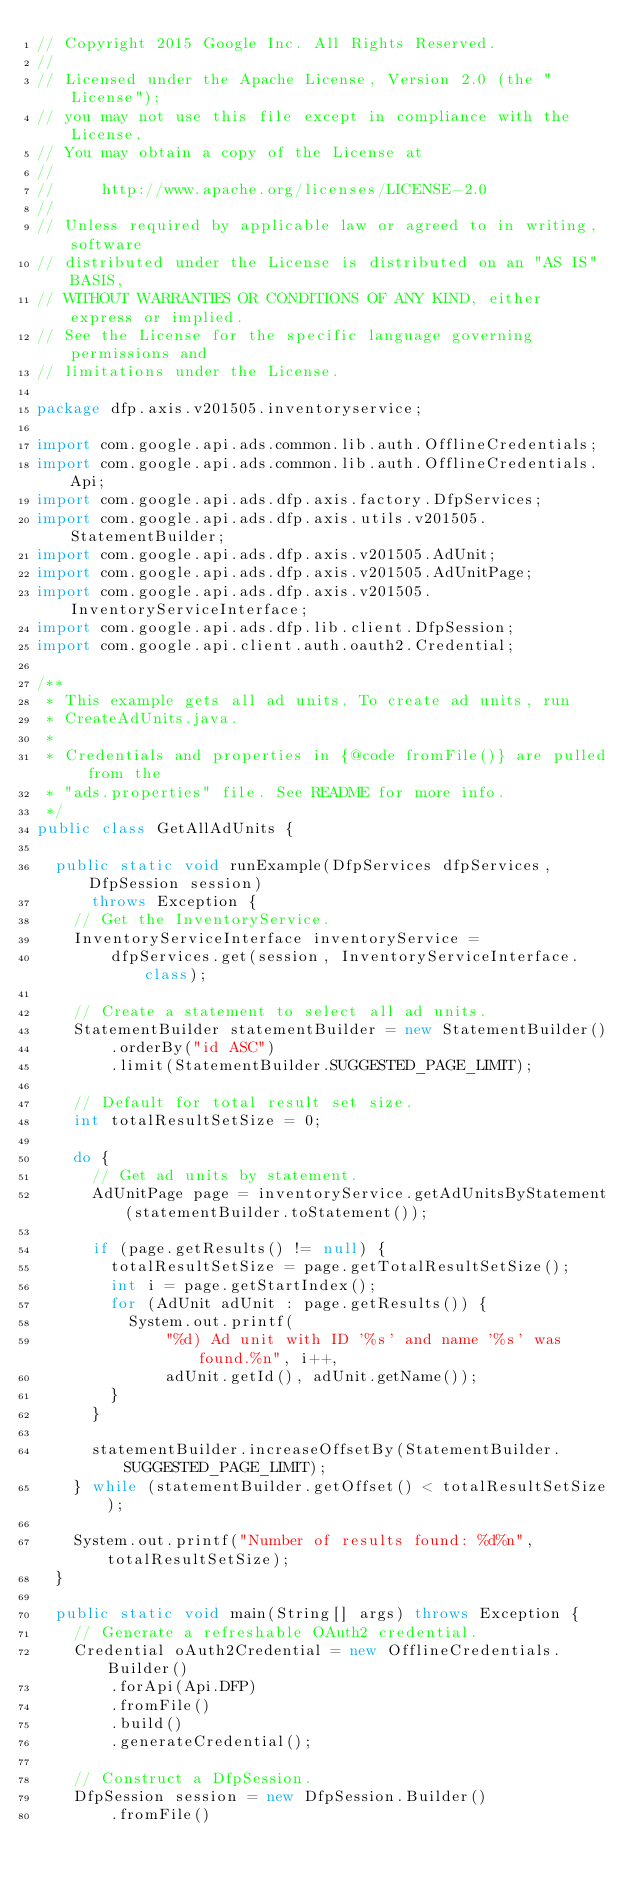Convert code to text. <code><loc_0><loc_0><loc_500><loc_500><_Java_>// Copyright 2015 Google Inc. All Rights Reserved.
//
// Licensed under the Apache License, Version 2.0 (the "License");
// you may not use this file except in compliance with the License.
// You may obtain a copy of the License at
//
//     http://www.apache.org/licenses/LICENSE-2.0
//
// Unless required by applicable law or agreed to in writing, software
// distributed under the License is distributed on an "AS IS" BASIS,
// WITHOUT WARRANTIES OR CONDITIONS OF ANY KIND, either express or implied.
// See the License for the specific language governing permissions and
// limitations under the License.

package dfp.axis.v201505.inventoryservice;

import com.google.api.ads.common.lib.auth.OfflineCredentials;
import com.google.api.ads.common.lib.auth.OfflineCredentials.Api;
import com.google.api.ads.dfp.axis.factory.DfpServices;
import com.google.api.ads.dfp.axis.utils.v201505.StatementBuilder;
import com.google.api.ads.dfp.axis.v201505.AdUnit;
import com.google.api.ads.dfp.axis.v201505.AdUnitPage;
import com.google.api.ads.dfp.axis.v201505.InventoryServiceInterface;
import com.google.api.ads.dfp.lib.client.DfpSession;
import com.google.api.client.auth.oauth2.Credential;

/**
 * This example gets all ad units. To create ad units, run
 * CreateAdUnits.java.
 *
 * Credentials and properties in {@code fromFile()} are pulled from the
 * "ads.properties" file. See README for more info.
 */
public class GetAllAdUnits {

  public static void runExample(DfpServices dfpServices, DfpSession session)
      throws Exception {
    // Get the InventoryService.
    InventoryServiceInterface inventoryService =
        dfpServices.get(session, InventoryServiceInterface.class);

    // Create a statement to select all ad units.
    StatementBuilder statementBuilder = new StatementBuilder()
        .orderBy("id ASC")
        .limit(StatementBuilder.SUGGESTED_PAGE_LIMIT);

    // Default for total result set size.
    int totalResultSetSize = 0;

    do {
      // Get ad units by statement.
      AdUnitPage page = inventoryService.getAdUnitsByStatement(statementBuilder.toStatement());

      if (page.getResults() != null) {
        totalResultSetSize = page.getTotalResultSetSize();
        int i = page.getStartIndex();
        for (AdUnit adUnit : page.getResults()) {
          System.out.printf(
              "%d) Ad unit with ID '%s' and name '%s' was found.%n", i++,
              adUnit.getId(), adUnit.getName());
        }
      }

      statementBuilder.increaseOffsetBy(StatementBuilder.SUGGESTED_PAGE_LIMIT);
    } while (statementBuilder.getOffset() < totalResultSetSize);

    System.out.printf("Number of results found: %d%n", totalResultSetSize);
  }

  public static void main(String[] args) throws Exception {
    // Generate a refreshable OAuth2 credential.
    Credential oAuth2Credential = new OfflineCredentials.Builder()
        .forApi(Api.DFP)
        .fromFile()
        .build()
        .generateCredential();

    // Construct a DfpSession.
    DfpSession session = new DfpSession.Builder()
        .fromFile()</code> 